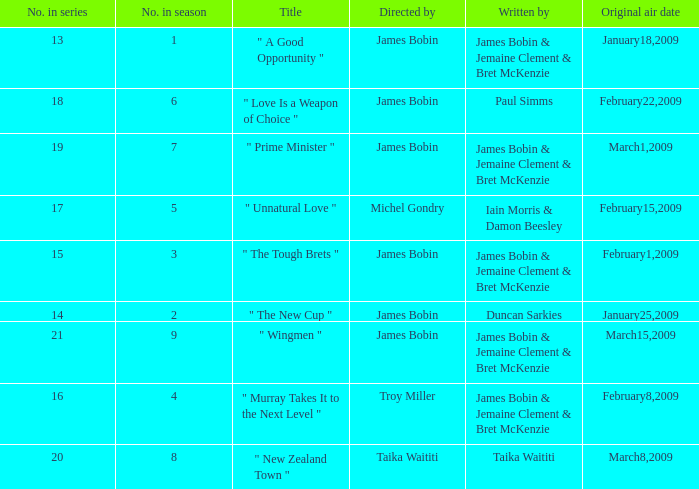Could you parse the entire table? {'header': ['No. in series', 'No. in season', 'Title', 'Directed by', 'Written by', 'Original air date'], 'rows': [['13', '1', '" A Good Opportunity "', 'James Bobin', 'James Bobin & Jemaine Clement & Bret McKenzie', 'January18,2009'], ['18', '6', '" Love Is a Weapon of Choice "', 'James Bobin', 'Paul Simms', 'February22,2009'], ['19', '7', '" Prime Minister "', 'James Bobin', 'James Bobin & Jemaine Clement & Bret McKenzie', 'March1,2009'], ['17', '5', '" Unnatural Love "', 'Michel Gondry', 'Iain Morris & Damon Beesley', 'February15,2009'], ['15', '3', '" The Tough Brets "', 'James Bobin', 'James Bobin & Jemaine Clement & Bret McKenzie', 'February1,2009'], ['14', '2', '" The New Cup "', 'James Bobin', 'Duncan Sarkies', 'January25,2009'], ['21', '9', '" Wingmen "', 'James Bobin', 'James Bobin & Jemaine Clement & Bret McKenzie', 'March15,2009'], ['16', '4', '" Murray Takes It to the Next Level "', 'Troy Miller', 'James Bobin & Jemaine Clement & Bret McKenzie', 'February8,2009'], ['20', '8', '" New Zealand Town "', 'Taika Waititi', 'Taika Waititi', 'March8,2009']]}  what's the original air date where written by is iain morris & damon beesley February15,2009. 